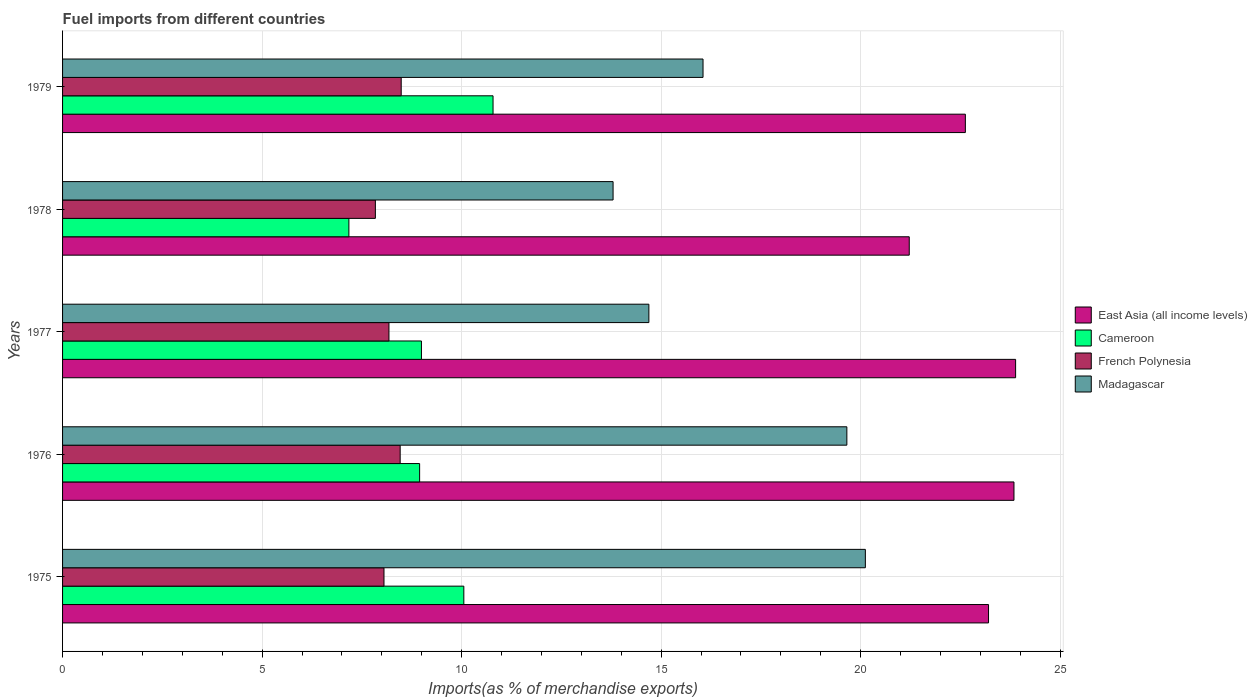How many different coloured bars are there?
Keep it short and to the point. 4. How many groups of bars are there?
Offer a terse response. 5. Are the number of bars on each tick of the Y-axis equal?
Give a very brief answer. Yes. What is the label of the 1st group of bars from the top?
Your answer should be very brief. 1979. What is the percentage of imports to different countries in French Polynesia in 1978?
Ensure brevity in your answer.  7.84. Across all years, what is the maximum percentage of imports to different countries in Cameroon?
Ensure brevity in your answer.  10.79. Across all years, what is the minimum percentage of imports to different countries in French Polynesia?
Provide a succinct answer. 7.84. In which year was the percentage of imports to different countries in East Asia (all income levels) minimum?
Ensure brevity in your answer.  1978. What is the total percentage of imports to different countries in Madagascar in the graph?
Offer a terse response. 84.31. What is the difference between the percentage of imports to different countries in East Asia (all income levels) in 1977 and that in 1979?
Give a very brief answer. 1.26. What is the difference between the percentage of imports to different countries in Cameroon in 1979 and the percentage of imports to different countries in French Polynesia in 1975?
Provide a succinct answer. 2.73. What is the average percentage of imports to different countries in French Polynesia per year?
Offer a terse response. 8.2. In the year 1976, what is the difference between the percentage of imports to different countries in Cameroon and percentage of imports to different countries in East Asia (all income levels)?
Keep it short and to the point. -14.89. In how many years, is the percentage of imports to different countries in Madagascar greater than 7 %?
Offer a terse response. 5. What is the ratio of the percentage of imports to different countries in Cameroon in 1976 to that in 1978?
Your answer should be very brief. 1.25. What is the difference between the highest and the second highest percentage of imports to different countries in Madagascar?
Ensure brevity in your answer.  0.46. What is the difference between the highest and the lowest percentage of imports to different countries in Cameroon?
Offer a terse response. 3.61. Is the sum of the percentage of imports to different countries in Madagascar in 1976 and 1979 greater than the maximum percentage of imports to different countries in East Asia (all income levels) across all years?
Offer a terse response. Yes. Is it the case that in every year, the sum of the percentage of imports to different countries in Madagascar and percentage of imports to different countries in French Polynesia is greater than the sum of percentage of imports to different countries in Cameroon and percentage of imports to different countries in East Asia (all income levels)?
Your answer should be very brief. No. What does the 1st bar from the top in 1979 represents?
Provide a short and direct response. Madagascar. What does the 4th bar from the bottom in 1978 represents?
Offer a very short reply. Madagascar. Is it the case that in every year, the sum of the percentage of imports to different countries in Cameroon and percentage of imports to different countries in East Asia (all income levels) is greater than the percentage of imports to different countries in Madagascar?
Offer a very short reply. Yes. How many bars are there?
Keep it short and to the point. 20. How many years are there in the graph?
Ensure brevity in your answer.  5. Does the graph contain any zero values?
Your answer should be very brief. No. Does the graph contain grids?
Offer a terse response. Yes. What is the title of the graph?
Make the answer very short. Fuel imports from different countries. Does "Isle of Man" appear as one of the legend labels in the graph?
Offer a terse response. No. What is the label or title of the X-axis?
Your answer should be very brief. Imports(as % of merchandise exports). What is the label or title of the Y-axis?
Your answer should be compact. Years. What is the Imports(as % of merchandise exports) in East Asia (all income levels) in 1975?
Give a very brief answer. 23.2. What is the Imports(as % of merchandise exports) of Cameroon in 1975?
Your answer should be very brief. 10.06. What is the Imports(as % of merchandise exports) in French Polynesia in 1975?
Keep it short and to the point. 8.05. What is the Imports(as % of merchandise exports) in Madagascar in 1975?
Your answer should be very brief. 20.12. What is the Imports(as % of merchandise exports) of East Asia (all income levels) in 1976?
Provide a short and direct response. 23.84. What is the Imports(as % of merchandise exports) of Cameroon in 1976?
Your answer should be compact. 8.95. What is the Imports(as % of merchandise exports) of French Polynesia in 1976?
Your answer should be compact. 8.46. What is the Imports(as % of merchandise exports) in Madagascar in 1976?
Make the answer very short. 19.65. What is the Imports(as % of merchandise exports) in East Asia (all income levels) in 1977?
Your answer should be compact. 23.88. What is the Imports(as % of merchandise exports) of Cameroon in 1977?
Provide a succinct answer. 8.99. What is the Imports(as % of merchandise exports) in French Polynesia in 1977?
Keep it short and to the point. 8.18. What is the Imports(as % of merchandise exports) in Madagascar in 1977?
Ensure brevity in your answer.  14.69. What is the Imports(as % of merchandise exports) of East Asia (all income levels) in 1978?
Make the answer very short. 21.22. What is the Imports(as % of merchandise exports) of Cameroon in 1978?
Ensure brevity in your answer.  7.17. What is the Imports(as % of merchandise exports) of French Polynesia in 1978?
Your answer should be compact. 7.84. What is the Imports(as % of merchandise exports) of Madagascar in 1978?
Make the answer very short. 13.8. What is the Imports(as % of merchandise exports) of East Asia (all income levels) in 1979?
Make the answer very short. 22.62. What is the Imports(as % of merchandise exports) in Cameroon in 1979?
Offer a terse response. 10.79. What is the Imports(as % of merchandise exports) of French Polynesia in 1979?
Give a very brief answer. 8.49. What is the Imports(as % of merchandise exports) in Madagascar in 1979?
Ensure brevity in your answer.  16.05. Across all years, what is the maximum Imports(as % of merchandise exports) in East Asia (all income levels)?
Your response must be concise. 23.88. Across all years, what is the maximum Imports(as % of merchandise exports) of Cameroon?
Your answer should be compact. 10.79. Across all years, what is the maximum Imports(as % of merchandise exports) of French Polynesia?
Provide a short and direct response. 8.49. Across all years, what is the maximum Imports(as % of merchandise exports) of Madagascar?
Ensure brevity in your answer.  20.12. Across all years, what is the minimum Imports(as % of merchandise exports) of East Asia (all income levels)?
Offer a terse response. 21.22. Across all years, what is the minimum Imports(as % of merchandise exports) in Cameroon?
Your answer should be compact. 7.17. Across all years, what is the minimum Imports(as % of merchandise exports) in French Polynesia?
Offer a terse response. 7.84. Across all years, what is the minimum Imports(as % of merchandise exports) of Madagascar?
Offer a terse response. 13.8. What is the total Imports(as % of merchandise exports) in East Asia (all income levels) in the graph?
Make the answer very short. 114.77. What is the total Imports(as % of merchandise exports) in Cameroon in the graph?
Provide a short and direct response. 45.96. What is the total Imports(as % of merchandise exports) in French Polynesia in the graph?
Offer a terse response. 41.02. What is the total Imports(as % of merchandise exports) of Madagascar in the graph?
Provide a short and direct response. 84.31. What is the difference between the Imports(as % of merchandise exports) in East Asia (all income levels) in 1975 and that in 1976?
Offer a terse response. -0.64. What is the difference between the Imports(as % of merchandise exports) of Cameroon in 1975 and that in 1976?
Keep it short and to the point. 1.11. What is the difference between the Imports(as % of merchandise exports) in French Polynesia in 1975 and that in 1976?
Offer a very short reply. -0.41. What is the difference between the Imports(as % of merchandise exports) in Madagascar in 1975 and that in 1976?
Make the answer very short. 0.46. What is the difference between the Imports(as % of merchandise exports) in East Asia (all income levels) in 1975 and that in 1977?
Make the answer very short. -0.68. What is the difference between the Imports(as % of merchandise exports) in Cameroon in 1975 and that in 1977?
Offer a very short reply. 1.06. What is the difference between the Imports(as % of merchandise exports) in French Polynesia in 1975 and that in 1977?
Provide a short and direct response. -0.12. What is the difference between the Imports(as % of merchandise exports) of Madagascar in 1975 and that in 1977?
Your response must be concise. 5.42. What is the difference between the Imports(as % of merchandise exports) of East Asia (all income levels) in 1975 and that in 1978?
Your response must be concise. 1.99. What is the difference between the Imports(as % of merchandise exports) of Cameroon in 1975 and that in 1978?
Ensure brevity in your answer.  2.88. What is the difference between the Imports(as % of merchandise exports) in French Polynesia in 1975 and that in 1978?
Provide a short and direct response. 0.22. What is the difference between the Imports(as % of merchandise exports) in Madagascar in 1975 and that in 1978?
Provide a short and direct response. 6.32. What is the difference between the Imports(as % of merchandise exports) in East Asia (all income levels) in 1975 and that in 1979?
Make the answer very short. 0.58. What is the difference between the Imports(as % of merchandise exports) in Cameroon in 1975 and that in 1979?
Your response must be concise. -0.73. What is the difference between the Imports(as % of merchandise exports) in French Polynesia in 1975 and that in 1979?
Your answer should be compact. -0.43. What is the difference between the Imports(as % of merchandise exports) of Madagascar in 1975 and that in 1979?
Provide a short and direct response. 4.07. What is the difference between the Imports(as % of merchandise exports) of East Asia (all income levels) in 1976 and that in 1977?
Offer a terse response. -0.04. What is the difference between the Imports(as % of merchandise exports) in Cameroon in 1976 and that in 1977?
Ensure brevity in your answer.  -0.05. What is the difference between the Imports(as % of merchandise exports) in French Polynesia in 1976 and that in 1977?
Give a very brief answer. 0.28. What is the difference between the Imports(as % of merchandise exports) in Madagascar in 1976 and that in 1977?
Offer a terse response. 4.96. What is the difference between the Imports(as % of merchandise exports) in East Asia (all income levels) in 1976 and that in 1978?
Provide a succinct answer. 2.62. What is the difference between the Imports(as % of merchandise exports) of Cameroon in 1976 and that in 1978?
Your answer should be very brief. 1.77. What is the difference between the Imports(as % of merchandise exports) in French Polynesia in 1976 and that in 1978?
Ensure brevity in your answer.  0.62. What is the difference between the Imports(as % of merchandise exports) in Madagascar in 1976 and that in 1978?
Your response must be concise. 5.86. What is the difference between the Imports(as % of merchandise exports) in East Asia (all income levels) in 1976 and that in 1979?
Provide a short and direct response. 1.22. What is the difference between the Imports(as % of merchandise exports) in Cameroon in 1976 and that in 1979?
Offer a very short reply. -1.84. What is the difference between the Imports(as % of merchandise exports) in French Polynesia in 1976 and that in 1979?
Provide a succinct answer. -0.03. What is the difference between the Imports(as % of merchandise exports) of Madagascar in 1976 and that in 1979?
Offer a very short reply. 3.6. What is the difference between the Imports(as % of merchandise exports) in East Asia (all income levels) in 1977 and that in 1978?
Give a very brief answer. 2.67. What is the difference between the Imports(as % of merchandise exports) in Cameroon in 1977 and that in 1978?
Ensure brevity in your answer.  1.82. What is the difference between the Imports(as % of merchandise exports) in French Polynesia in 1977 and that in 1978?
Your answer should be compact. 0.34. What is the difference between the Imports(as % of merchandise exports) of Madagascar in 1977 and that in 1978?
Provide a short and direct response. 0.9. What is the difference between the Imports(as % of merchandise exports) in East Asia (all income levels) in 1977 and that in 1979?
Ensure brevity in your answer.  1.26. What is the difference between the Imports(as % of merchandise exports) of Cameroon in 1977 and that in 1979?
Provide a short and direct response. -1.79. What is the difference between the Imports(as % of merchandise exports) in French Polynesia in 1977 and that in 1979?
Give a very brief answer. -0.31. What is the difference between the Imports(as % of merchandise exports) of Madagascar in 1977 and that in 1979?
Your answer should be very brief. -1.36. What is the difference between the Imports(as % of merchandise exports) in East Asia (all income levels) in 1978 and that in 1979?
Ensure brevity in your answer.  -1.41. What is the difference between the Imports(as % of merchandise exports) of Cameroon in 1978 and that in 1979?
Keep it short and to the point. -3.61. What is the difference between the Imports(as % of merchandise exports) in French Polynesia in 1978 and that in 1979?
Ensure brevity in your answer.  -0.65. What is the difference between the Imports(as % of merchandise exports) in Madagascar in 1978 and that in 1979?
Give a very brief answer. -2.25. What is the difference between the Imports(as % of merchandise exports) of East Asia (all income levels) in 1975 and the Imports(as % of merchandise exports) of Cameroon in 1976?
Offer a very short reply. 14.26. What is the difference between the Imports(as % of merchandise exports) of East Asia (all income levels) in 1975 and the Imports(as % of merchandise exports) of French Polynesia in 1976?
Make the answer very short. 14.74. What is the difference between the Imports(as % of merchandise exports) in East Asia (all income levels) in 1975 and the Imports(as % of merchandise exports) in Madagascar in 1976?
Offer a terse response. 3.55. What is the difference between the Imports(as % of merchandise exports) in Cameroon in 1975 and the Imports(as % of merchandise exports) in French Polynesia in 1976?
Give a very brief answer. 1.6. What is the difference between the Imports(as % of merchandise exports) of Cameroon in 1975 and the Imports(as % of merchandise exports) of Madagascar in 1976?
Make the answer very short. -9.6. What is the difference between the Imports(as % of merchandise exports) in French Polynesia in 1975 and the Imports(as % of merchandise exports) in Madagascar in 1976?
Provide a short and direct response. -11.6. What is the difference between the Imports(as % of merchandise exports) in East Asia (all income levels) in 1975 and the Imports(as % of merchandise exports) in Cameroon in 1977?
Ensure brevity in your answer.  14.21. What is the difference between the Imports(as % of merchandise exports) in East Asia (all income levels) in 1975 and the Imports(as % of merchandise exports) in French Polynesia in 1977?
Provide a short and direct response. 15.02. What is the difference between the Imports(as % of merchandise exports) of East Asia (all income levels) in 1975 and the Imports(as % of merchandise exports) of Madagascar in 1977?
Make the answer very short. 8.51. What is the difference between the Imports(as % of merchandise exports) in Cameroon in 1975 and the Imports(as % of merchandise exports) in French Polynesia in 1977?
Your response must be concise. 1.88. What is the difference between the Imports(as % of merchandise exports) of Cameroon in 1975 and the Imports(as % of merchandise exports) of Madagascar in 1977?
Your response must be concise. -4.64. What is the difference between the Imports(as % of merchandise exports) of French Polynesia in 1975 and the Imports(as % of merchandise exports) of Madagascar in 1977?
Your response must be concise. -6.64. What is the difference between the Imports(as % of merchandise exports) of East Asia (all income levels) in 1975 and the Imports(as % of merchandise exports) of Cameroon in 1978?
Ensure brevity in your answer.  16.03. What is the difference between the Imports(as % of merchandise exports) of East Asia (all income levels) in 1975 and the Imports(as % of merchandise exports) of French Polynesia in 1978?
Ensure brevity in your answer.  15.37. What is the difference between the Imports(as % of merchandise exports) in East Asia (all income levels) in 1975 and the Imports(as % of merchandise exports) in Madagascar in 1978?
Provide a short and direct response. 9.41. What is the difference between the Imports(as % of merchandise exports) in Cameroon in 1975 and the Imports(as % of merchandise exports) in French Polynesia in 1978?
Offer a very short reply. 2.22. What is the difference between the Imports(as % of merchandise exports) in Cameroon in 1975 and the Imports(as % of merchandise exports) in Madagascar in 1978?
Your answer should be very brief. -3.74. What is the difference between the Imports(as % of merchandise exports) of French Polynesia in 1975 and the Imports(as % of merchandise exports) of Madagascar in 1978?
Make the answer very short. -5.74. What is the difference between the Imports(as % of merchandise exports) of East Asia (all income levels) in 1975 and the Imports(as % of merchandise exports) of Cameroon in 1979?
Offer a very short reply. 12.42. What is the difference between the Imports(as % of merchandise exports) of East Asia (all income levels) in 1975 and the Imports(as % of merchandise exports) of French Polynesia in 1979?
Your response must be concise. 14.72. What is the difference between the Imports(as % of merchandise exports) of East Asia (all income levels) in 1975 and the Imports(as % of merchandise exports) of Madagascar in 1979?
Give a very brief answer. 7.15. What is the difference between the Imports(as % of merchandise exports) of Cameroon in 1975 and the Imports(as % of merchandise exports) of French Polynesia in 1979?
Provide a short and direct response. 1.57. What is the difference between the Imports(as % of merchandise exports) in Cameroon in 1975 and the Imports(as % of merchandise exports) in Madagascar in 1979?
Offer a terse response. -5.99. What is the difference between the Imports(as % of merchandise exports) of French Polynesia in 1975 and the Imports(as % of merchandise exports) of Madagascar in 1979?
Your answer should be compact. -8. What is the difference between the Imports(as % of merchandise exports) of East Asia (all income levels) in 1976 and the Imports(as % of merchandise exports) of Cameroon in 1977?
Give a very brief answer. 14.85. What is the difference between the Imports(as % of merchandise exports) of East Asia (all income levels) in 1976 and the Imports(as % of merchandise exports) of French Polynesia in 1977?
Give a very brief answer. 15.66. What is the difference between the Imports(as % of merchandise exports) of East Asia (all income levels) in 1976 and the Imports(as % of merchandise exports) of Madagascar in 1977?
Give a very brief answer. 9.15. What is the difference between the Imports(as % of merchandise exports) of Cameroon in 1976 and the Imports(as % of merchandise exports) of French Polynesia in 1977?
Keep it short and to the point. 0.77. What is the difference between the Imports(as % of merchandise exports) in Cameroon in 1976 and the Imports(as % of merchandise exports) in Madagascar in 1977?
Provide a succinct answer. -5.74. What is the difference between the Imports(as % of merchandise exports) of French Polynesia in 1976 and the Imports(as % of merchandise exports) of Madagascar in 1977?
Make the answer very short. -6.23. What is the difference between the Imports(as % of merchandise exports) in East Asia (all income levels) in 1976 and the Imports(as % of merchandise exports) in Cameroon in 1978?
Ensure brevity in your answer.  16.67. What is the difference between the Imports(as % of merchandise exports) in East Asia (all income levels) in 1976 and the Imports(as % of merchandise exports) in French Polynesia in 1978?
Your answer should be very brief. 16. What is the difference between the Imports(as % of merchandise exports) in East Asia (all income levels) in 1976 and the Imports(as % of merchandise exports) in Madagascar in 1978?
Your answer should be compact. 10.05. What is the difference between the Imports(as % of merchandise exports) in Cameroon in 1976 and the Imports(as % of merchandise exports) in French Polynesia in 1978?
Your response must be concise. 1.11. What is the difference between the Imports(as % of merchandise exports) of Cameroon in 1976 and the Imports(as % of merchandise exports) of Madagascar in 1978?
Your answer should be compact. -4.85. What is the difference between the Imports(as % of merchandise exports) of French Polynesia in 1976 and the Imports(as % of merchandise exports) of Madagascar in 1978?
Your answer should be compact. -5.33. What is the difference between the Imports(as % of merchandise exports) of East Asia (all income levels) in 1976 and the Imports(as % of merchandise exports) of Cameroon in 1979?
Provide a short and direct response. 13.05. What is the difference between the Imports(as % of merchandise exports) of East Asia (all income levels) in 1976 and the Imports(as % of merchandise exports) of French Polynesia in 1979?
Make the answer very short. 15.36. What is the difference between the Imports(as % of merchandise exports) in East Asia (all income levels) in 1976 and the Imports(as % of merchandise exports) in Madagascar in 1979?
Keep it short and to the point. 7.79. What is the difference between the Imports(as % of merchandise exports) of Cameroon in 1976 and the Imports(as % of merchandise exports) of French Polynesia in 1979?
Offer a very short reply. 0.46. What is the difference between the Imports(as % of merchandise exports) in Cameroon in 1976 and the Imports(as % of merchandise exports) in Madagascar in 1979?
Make the answer very short. -7.1. What is the difference between the Imports(as % of merchandise exports) of French Polynesia in 1976 and the Imports(as % of merchandise exports) of Madagascar in 1979?
Provide a short and direct response. -7.59. What is the difference between the Imports(as % of merchandise exports) in East Asia (all income levels) in 1977 and the Imports(as % of merchandise exports) in Cameroon in 1978?
Make the answer very short. 16.71. What is the difference between the Imports(as % of merchandise exports) in East Asia (all income levels) in 1977 and the Imports(as % of merchandise exports) in French Polynesia in 1978?
Your response must be concise. 16.04. What is the difference between the Imports(as % of merchandise exports) of East Asia (all income levels) in 1977 and the Imports(as % of merchandise exports) of Madagascar in 1978?
Provide a short and direct response. 10.09. What is the difference between the Imports(as % of merchandise exports) of Cameroon in 1977 and the Imports(as % of merchandise exports) of French Polynesia in 1978?
Provide a short and direct response. 1.15. What is the difference between the Imports(as % of merchandise exports) in Cameroon in 1977 and the Imports(as % of merchandise exports) in Madagascar in 1978?
Give a very brief answer. -4.8. What is the difference between the Imports(as % of merchandise exports) of French Polynesia in 1977 and the Imports(as % of merchandise exports) of Madagascar in 1978?
Keep it short and to the point. -5.62. What is the difference between the Imports(as % of merchandise exports) of East Asia (all income levels) in 1977 and the Imports(as % of merchandise exports) of Cameroon in 1979?
Your answer should be very brief. 13.09. What is the difference between the Imports(as % of merchandise exports) of East Asia (all income levels) in 1977 and the Imports(as % of merchandise exports) of French Polynesia in 1979?
Ensure brevity in your answer.  15.4. What is the difference between the Imports(as % of merchandise exports) of East Asia (all income levels) in 1977 and the Imports(as % of merchandise exports) of Madagascar in 1979?
Offer a terse response. 7.83. What is the difference between the Imports(as % of merchandise exports) in Cameroon in 1977 and the Imports(as % of merchandise exports) in French Polynesia in 1979?
Ensure brevity in your answer.  0.51. What is the difference between the Imports(as % of merchandise exports) of Cameroon in 1977 and the Imports(as % of merchandise exports) of Madagascar in 1979?
Your answer should be very brief. -7.06. What is the difference between the Imports(as % of merchandise exports) in French Polynesia in 1977 and the Imports(as % of merchandise exports) in Madagascar in 1979?
Your answer should be compact. -7.87. What is the difference between the Imports(as % of merchandise exports) in East Asia (all income levels) in 1978 and the Imports(as % of merchandise exports) in Cameroon in 1979?
Provide a short and direct response. 10.43. What is the difference between the Imports(as % of merchandise exports) in East Asia (all income levels) in 1978 and the Imports(as % of merchandise exports) in French Polynesia in 1979?
Keep it short and to the point. 12.73. What is the difference between the Imports(as % of merchandise exports) in East Asia (all income levels) in 1978 and the Imports(as % of merchandise exports) in Madagascar in 1979?
Ensure brevity in your answer.  5.17. What is the difference between the Imports(as % of merchandise exports) in Cameroon in 1978 and the Imports(as % of merchandise exports) in French Polynesia in 1979?
Give a very brief answer. -1.31. What is the difference between the Imports(as % of merchandise exports) in Cameroon in 1978 and the Imports(as % of merchandise exports) in Madagascar in 1979?
Ensure brevity in your answer.  -8.87. What is the difference between the Imports(as % of merchandise exports) of French Polynesia in 1978 and the Imports(as % of merchandise exports) of Madagascar in 1979?
Keep it short and to the point. -8.21. What is the average Imports(as % of merchandise exports) of East Asia (all income levels) per year?
Make the answer very short. 22.95. What is the average Imports(as % of merchandise exports) of Cameroon per year?
Your response must be concise. 9.19. What is the average Imports(as % of merchandise exports) of French Polynesia per year?
Your answer should be very brief. 8.2. What is the average Imports(as % of merchandise exports) in Madagascar per year?
Offer a very short reply. 16.86. In the year 1975, what is the difference between the Imports(as % of merchandise exports) of East Asia (all income levels) and Imports(as % of merchandise exports) of Cameroon?
Keep it short and to the point. 13.15. In the year 1975, what is the difference between the Imports(as % of merchandise exports) of East Asia (all income levels) and Imports(as % of merchandise exports) of French Polynesia?
Make the answer very short. 15.15. In the year 1975, what is the difference between the Imports(as % of merchandise exports) of East Asia (all income levels) and Imports(as % of merchandise exports) of Madagascar?
Ensure brevity in your answer.  3.09. In the year 1975, what is the difference between the Imports(as % of merchandise exports) in Cameroon and Imports(as % of merchandise exports) in French Polynesia?
Keep it short and to the point. 2. In the year 1975, what is the difference between the Imports(as % of merchandise exports) of Cameroon and Imports(as % of merchandise exports) of Madagascar?
Keep it short and to the point. -10.06. In the year 1975, what is the difference between the Imports(as % of merchandise exports) in French Polynesia and Imports(as % of merchandise exports) in Madagascar?
Make the answer very short. -12.06. In the year 1976, what is the difference between the Imports(as % of merchandise exports) of East Asia (all income levels) and Imports(as % of merchandise exports) of Cameroon?
Your response must be concise. 14.89. In the year 1976, what is the difference between the Imports(as % of merchandise exports) of East Asia (all income levels) and Imports(as % of merchandise exports) of French Polynesia?
Give a very brief answer. 15.38. In the year 1976, what is the difference between the Imports(as % of merchandise exports) in East Asia (all income levels) and Imports(as % of merchandise exports) in Madagascar?
Give a very brief answer. 4.19. In the year 1976, what is the difference between the Imports(as % of merchandise exports) in Cameroon and Imports(as % of merchandise exports) in French Polynesia?
Provide a short and direct response. 0.49. In the year 1976, what is the difference between the Imports(as % of merchandise exports) of Cameroon and Imports(as % of merchandise exports) of Madagascar?
Provide a succinct answer. -10.71. In the year 1976, what is the difference between the Imports(as % of merchandise exports) in French Polynesia and Imports(as % of merchandise exports) in Madagascar?
Make the answer very short. -11.19. In the year 1977, what is the difference between the Imports(as % of merchandise exports) in East Asia (all income levels) and Imports(as % of merchandise exports) in Cameroon?
Your answer should be very brief. 14.89. In the year 1977, what is the difference between the Imports(as % of merchandise exports) of East Asia (all income levels) and Imports(as % of merchandise exports) of French Polynesia?
Your response must be concise. 15.7. In the year 1977, what is the difference between the Imports(as % of merchandise exports) of East Asia (all income levels) and Imports(as % of merchandise exports) of Madagascar?
Offer a terse response. 9.19. In the year 1977, what is the difference between the Imports(as % of merchandise exports) of Cameroon and Imports(as % of merchandise exports) of French Polynesia?
Offer a terse response. 0.81. In the year 1977, what is the difference between the Imports(as % of merchandise exports) in Cameroon and Imports(as % of merchandise exports) in Madagascar?
Provide a succinct answer. -5.7. In the year 1977, what is the difference between the Imports(as % of merchandise exports) in French Polynesia and Imports(as % of merchandise exports) in Madagascar?
Ensure brevity in your answer.  -6.51. In the year 1978, what is the difference between the Imports(as % of merchandise exports) of East Asia (all income levels) and Imports(as % of merchandise exports) of Cameroon?
Your response must be concise. 14.04. In the year 1978, what is the difference between the Imports(as % of merchandise exports) of East Asia (all income levels) and Imports(as % of merchandise exports) of French Polynesia?
Provide a short and direct response. 13.38. In the year 1978, what is the difference between the Imports(as % of merchandise exports) in East Asia (all income levels) and Imports(as % of merchandise exports) in Madagascar?
Give a very brief answer. 7.42. In the year 1978, what is the difference between the Imports(as % of merchandise exports) of Cameroon and Imports(as % of merchandise exports) of French Polynesia?
Provide a short and direct response. -0.66. In the year 1978, what is the difference between the Imports(as % of merchandise exports) in Cameroon and Imports(as % of merchandise exports) in Madagascar?
Give a very brief answer. -6.62. In the year 1978, what is the difference between the Imports(as % of merchandise exports) of French Polynesia and Imports(as % of merchandise exports) of Madagascar?
Provide a short and direct response. -5.96. In the year 1979, what is the difference between the Imports(as % of merchandise exports) of East Asia (all income levels) and Imports(as % of merchandise exports) of Cameroon?
Your response must be concise. 11.84. In the year 1979, what is the difference between the Imports(as % of merchandise exports) of East Asia (all income levels) and Imports(as % of merchandise exports) of French Polynesia?
Keep it short and to the point. 14.14. In the year 1979, what is the difference between the Imports(as % of merchandise exports) of East Asia (all income levels) and Imports(as % of merchandise exports) of Madagascar?
Ensure brevity in your answer.  6.57. In the year 1979, what is the difference between the Imports(as % of merchandise exports) of Cameroon and Imports(as % of merchandise exports) of French Polynesia?
Provide a short and direct response. 2.3. In the year 1979, what is the difference between the Imports(as % of merchandise exports) of Cameroon and Imports(as % of merchandise exports) of Madagascar?
Offer a terse response. -5.26. In the year 1979, what is the difference between the Imports(as % of merchandise exports) in French Polynesia and Imports(as % of merchandise exports) in Madagascar?
Ensure brevity in your answer.  -7.56. What is the ratio of the Imports(as % of merchandise exports) in East Asia (all income levels) in 1975 to that in 1976?
Your answer should be compact. 0.97. What is the ratio of the Imports(as % of merchandise exports) of Cameroon in 1975 to that in 1976?
Keep it short and to the point. 1.12. What is the ratio of the Imports(as % of merchandise exports) of Madagascar in 1975 to that in 1976?
Give a very brief answer. 1.02. What is the ratio of the Imports(as % of merchandise exports) of East Asia (all income levels) in 1975 to that in 1977?
Ensure brevity in your answer.  0.97. What is the ratio of the Imports(as % of merchandise exports) in Cameroon in 1975 to that in 1977?
Provide a short and direct response. 1.12. What is the ratio of the Imports(as % of merchandise exports) of Madagascar in 1975 to that in 1977?
Ensure brevity in your answer.  1.37. What is the ratio of the Imports(as % of merchandise exports) of East Asia (all income levels) in 1975 to that in 1978?
Offer a terse response. 1.09. What is the ratio of the Imports(as % of merchandise exports) in Cameroon in 1975 to that in 1978?
Your response must be concise. 1.4. What is the ratio of the Imports(as % of merchandise exports) in French Polynesia in 1975 to that in 1978?
Your response must be concise. 1.03. What is the ratio of the Imports(as % of merchandise exports) of Madagascar in 1975 to that in 1978?
Give a very brief answer. 1.46. What is the ratio of the Imports(as % of merchandise exports) in East Asia (all income levels) in 1975 to that in 1979?
Keep it short and to the point. 1.03. What is the ratio of the Imports(as % of merchandise exports) in Cameroon in 1975 to that in 1979?
Make the answer very short. 0.93. What is the ratio of the Imports(as % of merchandise exports) in French Polynesia in 1975 to that in 1979?
Make the answer very short. 0.95. What is the ratio of the Imports(as % of merchandise exports) of Madagascar in 1975 to that in 1979?
Provide a succinct answer. 1.25. What is the ratio of the Imports(as % of merchandise exports) in French Polynesia in 1976 to that in 1977?
Your response must be concise. 1.03. What is the ratio of the Imports(as % of merchandise exports) of Madagascar in 1976 to that in 1977?
Provide a short and direct response. 1.34. What is the ratio of the Imports(as % of merchandise exports) in East Asia (all income levels) in 1976 to that in 1978?
Make the answer very short. 1.12. What is the ratio of the Imports(as % of merchandise exports) in Cameroon in 1976 to that in 1978?
Make the answer very short. 1.25. What is the ratio of the Imports(as % of merchandise exports) in French Polynesia in 1976 to that in 1978?
Offer a very short reply. 1.08. What is the ratio of the Imports(as % of merchandise exports) of Madagascar in 1976 to that in 1978?
Your answer should be compact. 1.42. What is the ratio of the Imports(as % of merchandise exports) of East Asia (all income levels) in 1976 to that in 1979?
Keep it short and to the point. 1.05. What is the ratio of the Imports(as % of merchandise exports) in Cameroon in 1976 to that in 1979?
Your answer should be compact. 0.83. What is the ratio of the Imports(as % of merchandise exports) in French Polynesia in 1976 to that in 1979?
Your response must be concise. 1. What is the ratio of the Imports(as % of merchandise exports) of Madagascar in 1976 to that in 1979?
Keep it short and to the point. 1.22. What is the ratio of the Imports(as % of merchandise exports) of East Asia (all income levels) in 1977 to that in 1978?
Keep it short and to the point. 1.13. What is the ratio of the Imports(as % of merchandise exports) of Cameroon in 1977 to that in 1978?
Offer a terse response. 1.25. What is the ratio of the Imports(as % of merchandise exports) in French Polynesia in 1977 to that in 1978?
Provide a succinct answer. 1.04. What is the ratio of the Imports(as % of merchandise exports) of Madagascar in 1977 to that in 1978?
Offer a terse response. 1.06. What is the ratio of the Imports(as % of merchandise exports) of East Asia (all income levels) in 1977 to that in 1979?
Your response must be concise. 1.06. What is the ratio of the Imports(as % of merchandise exports) of Cameroon in 1977 to that in 1979?
Your answer should be compact. 0.83. What is the ratio of the Imports(as % of merchandise exports) in French Polynesia in 1977 to that in 1979?
Make the answer very short. 0.96. What is the ratio of the Imports(as % of merchandise exports) in Madagascar in 1977 to that in 1979?
Give a very brief answer. 0.92. What is the ratio of the Imports(as % of merchandise exports) of East Asia (all income levels) in 1978 to that in 1979?
Ensure brevity in your answer.  0.94. What is the ratio of the Imports(as % of merchandise exports) of Cameroon in 1978 to that in 1979?
Your answer should be compact. 0.67. What is the ratio of the Imports(as % of merchandise exports) in French Polynesia in 1978 to that in 1979?
Ensure brevity in your answer.  0.92. What is the ratio of the Imports(as % of merchandise exports) in Madagascar in 1978 to that in 1979?
Offer a terse response. 0.86. What is the difference between the highest and the second highest Imports(as % of merchandise exports) in East Asia (all income levels)?
Ensure brevity in your answer.  0.04. What is the difference between the highest and the second highest Imports(as % of merchandise exports) in Cameroon?
Provide a succinct answer. 0.73. What is the difference between the highest and the second highest Imports(as % of merchandise exports) in French Polynesia?
Offer a very short reply. 0.03. What is the difference between the highest and the second highest Imports(as % of merchandise exports) in Madagascar?
Your answer should be compact. 0.46. What is the difference between the highest and the lowest Imports(as % of merchandise exports) of East Asia (all income levels)?
Your answer should be very brief. 2.67. What is the difference between the highest and the lowest Imports(as % of merchandise exports) of Cameroon?
Your answer should be compact. 3.61. What is the difference between the highest and the lowest Imports(as % of merchandise exports) of French Polynesia?
Make the answer very short. 0.65. What is the difference between the highest and the lowest Imports(as % of merchandise exports) in Madagascar?
Keep it short and to the point. 6.32. 